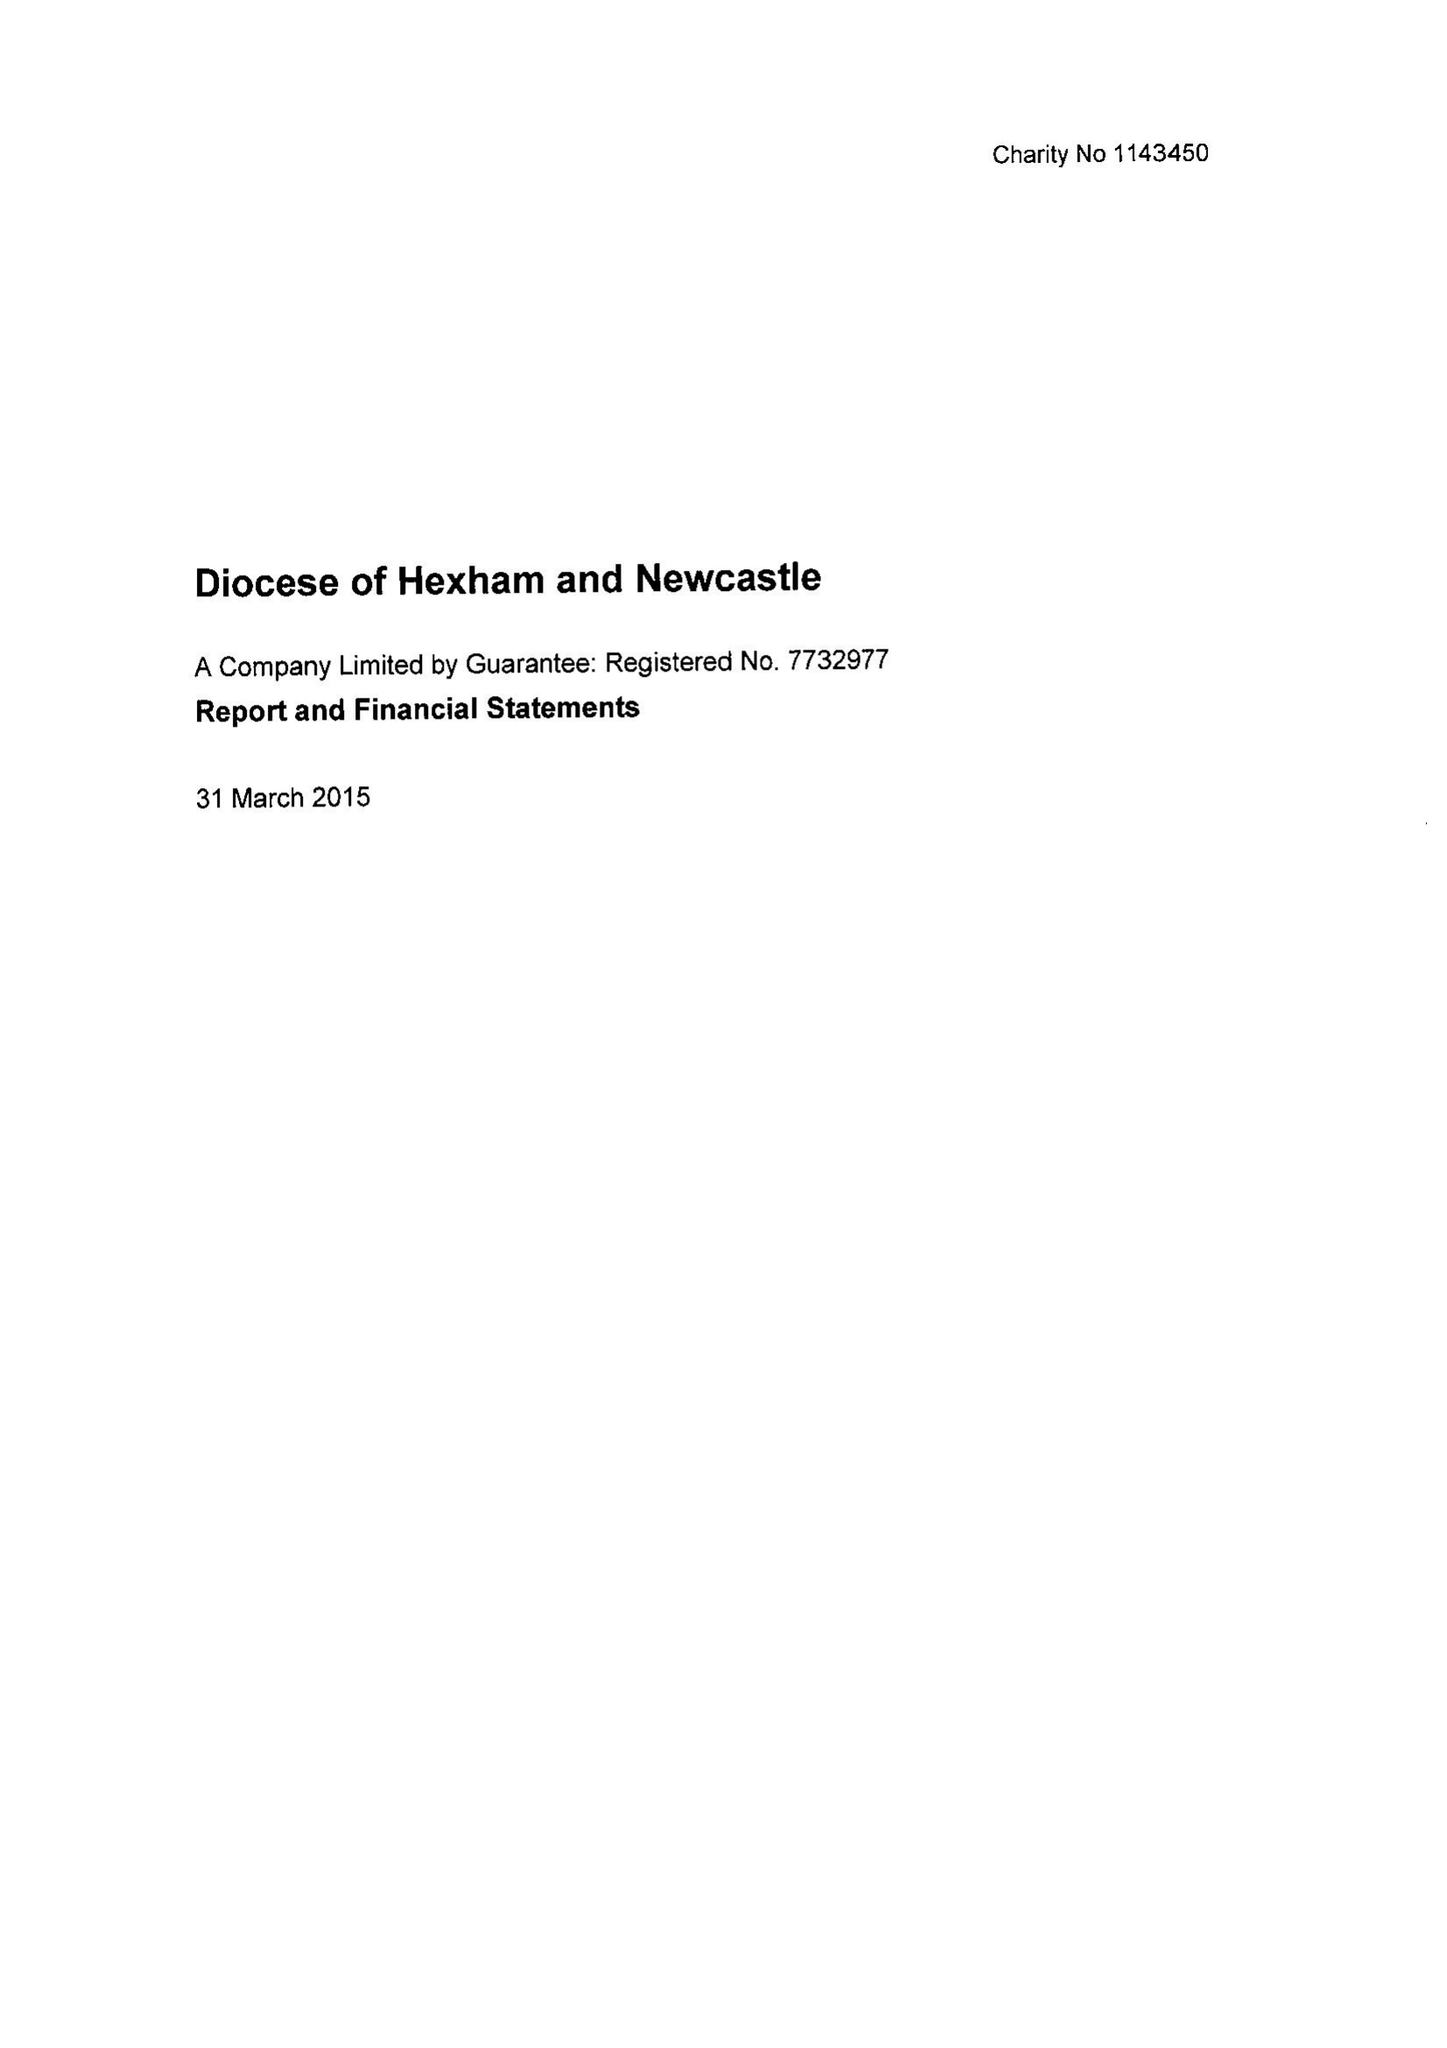What is the value for the address__post_town?
Answer the question using a single word or phrase. NEWCASTLE UPON TYNE 